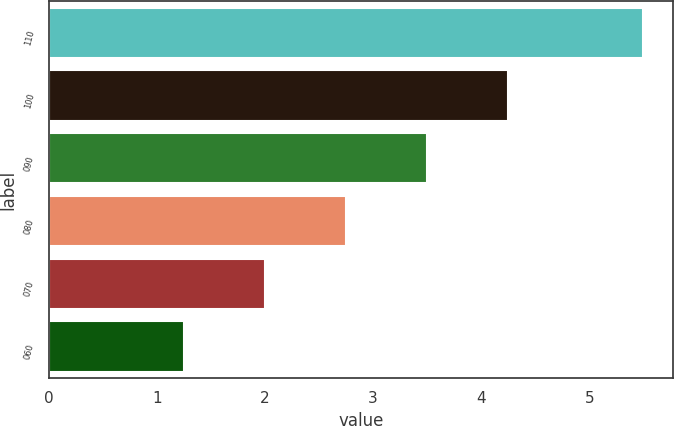<chart> <loc_0><loc_0><loc_500><loc_500><bar_chart><fcel>110<fcel>100<fcel>090<fcel>080<fcel>070<fcel>060<nl><fcel>5.5<fcel>4.25<fcel>3.5<fcel>2.75<fcel>2<fcel>1.25<nl></chart> 